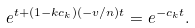Convert formula to latex. <formula><loc_0><loc_0><loc_500><loc_500>e ^ { t + ( 1 - k c _ { k } ) ( - v / n ) t } = e ^ { - c _ { k } t } .</formula> 